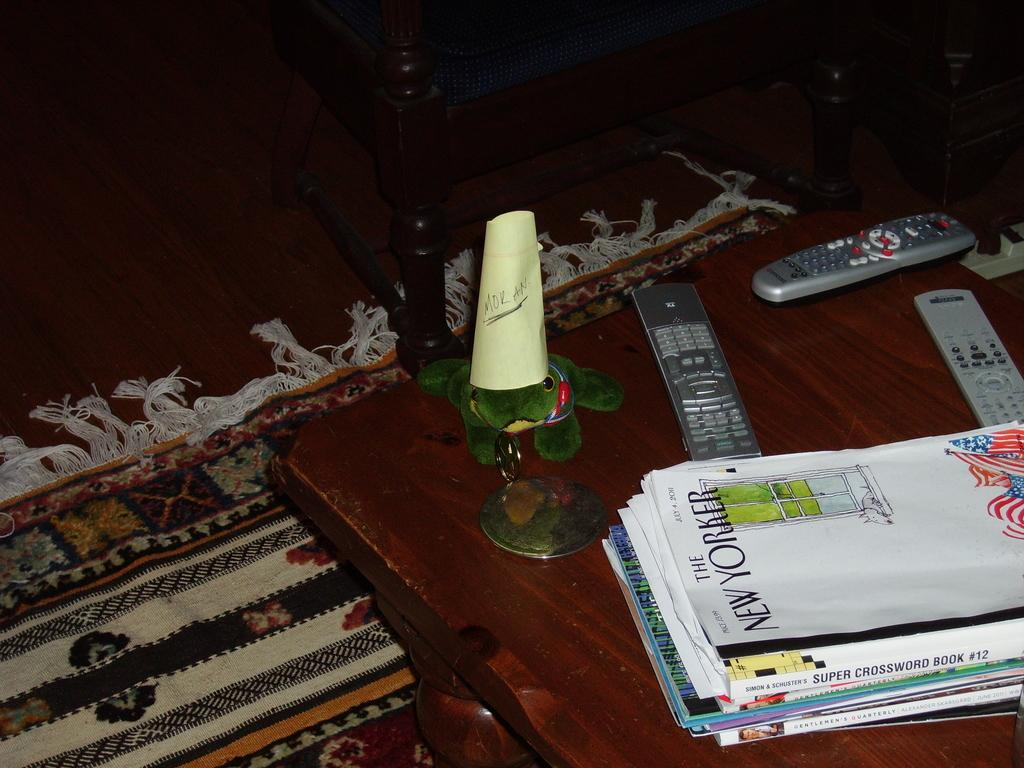<image>
Create a compact narrative representing the image presented. A small metal stand with a yellow paper that says Mor An underlined standing on a coffee table 